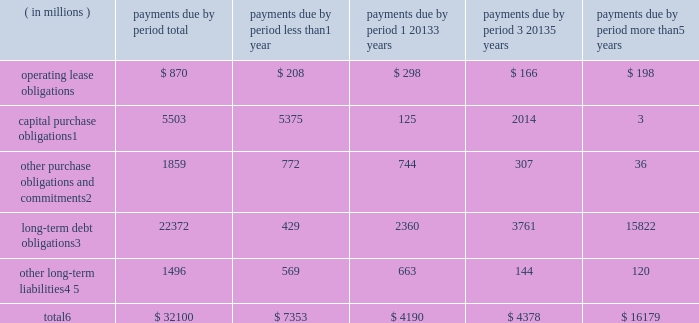Contractual obligations the table summarizes our significant contractual obligations as of december 28 , 2013: .
Capital purchase obligations1 5503 5375 125 2014 3 other purchase obligations and commitments2 1859 772 744 307 36 long-term debt obligations3 22372 429 2360 3761 15822 other long-term liabilities4 , 5 1496 569 663 144 120 total6 $ 32100 $ 7353 $ 4190 $ 4378 $ 16179 1 capital purchase obligations represent commitments for the construction or purchase of property , plant and equipment .
They were not recorded as liabilities on our consolidated balance sheets as of december 28 , 2013 , as we had not yet received the related goods or taken title to the property .
2 other purchase obligations and commitments include payments due under various types of licenses and agreements to purchase goods or services , as well as payments due under non-contingent funding obligations .
Funding obligations include agreements to fund various projects with other companies .
3 amounts represent principal and interest cash payments over the life of the debt obligations , including anticipated interest payments that are not recorded on our consolidated balance sheets .
Any future settlement of convertible debt would impact our cash payments .
4 we are unable to reliably estimate the timing of future payments related to uncertain tax positions ; therefore , $ 188 million of long-term income taxes payable has been excluded from the preceding table .
However , long- term income taxes payable , recorded on our consolidated balance sheets , included these uncertain tax positions , reduced by the associated federal deduction for state taxes and u.s .
Tax credits arising from non- u.s .
Income taxes .
5 amounts represent future cash payments to satisfy other long-term liabilities recorded on our consolidated balance sheets , including the short-term portion of these long-term liabilities .
Expected required contributions to our u.s .
And non-u.s .
Pension plans and other postretirement benefit plans of $ 62 million to be made during 2014 are also included ; however , funding projections beyond 2014 are not practicable to estimate .
6 total excludes contractual obligations already recorded on our consolidated balance sheets as current liabilities except for the short-term portions of long-term debt obligations and other long-term liabilities .
Contractual obligations for purchases of goods or services , included in other purchase obligations and commitments in the preceding table , include agreements that are enforceable and legally binding on intel and that specify all significant terms , including fixed or minimum quantities to be purchased ; fixed , minimum , or variable price provisions ; and the approximate timing of the transaction .
For obligations with cancellation provisions , the amounts included in the preceding table were limited to the non-cancelable portion of the agreement terms or the minimum cancellation fee .
We have entered into certain agreements for the purchase of raw materials that specify minimum prices and quantities based on a percentage of the total available market or based on a percentage of our future purchasing requirements .
Due to the uncertainty of the future market and our future purchasing requirements , as well as the non-binding nature of these agreements , obligations under these agreements are not included in the preceding table .
Our purchase orders for other products are based on our current manufacturing needs and are fulfilled by our vendors within short time horizons .
In addition , some of our purchase orders represent authorizations to purchase rather than binding agreements .
Table of contents management 2019s discussion and analysis of financial condition and results of operations ( continued ) .
As of december 28 , 2013 capital purchase obligations to the total of the total? 
Rationale: as of december 28 , 2013 the total amount was made of 17.1% capital purchase obligations
Computations: (5503 / 32100)
Answer: 0.17143. 